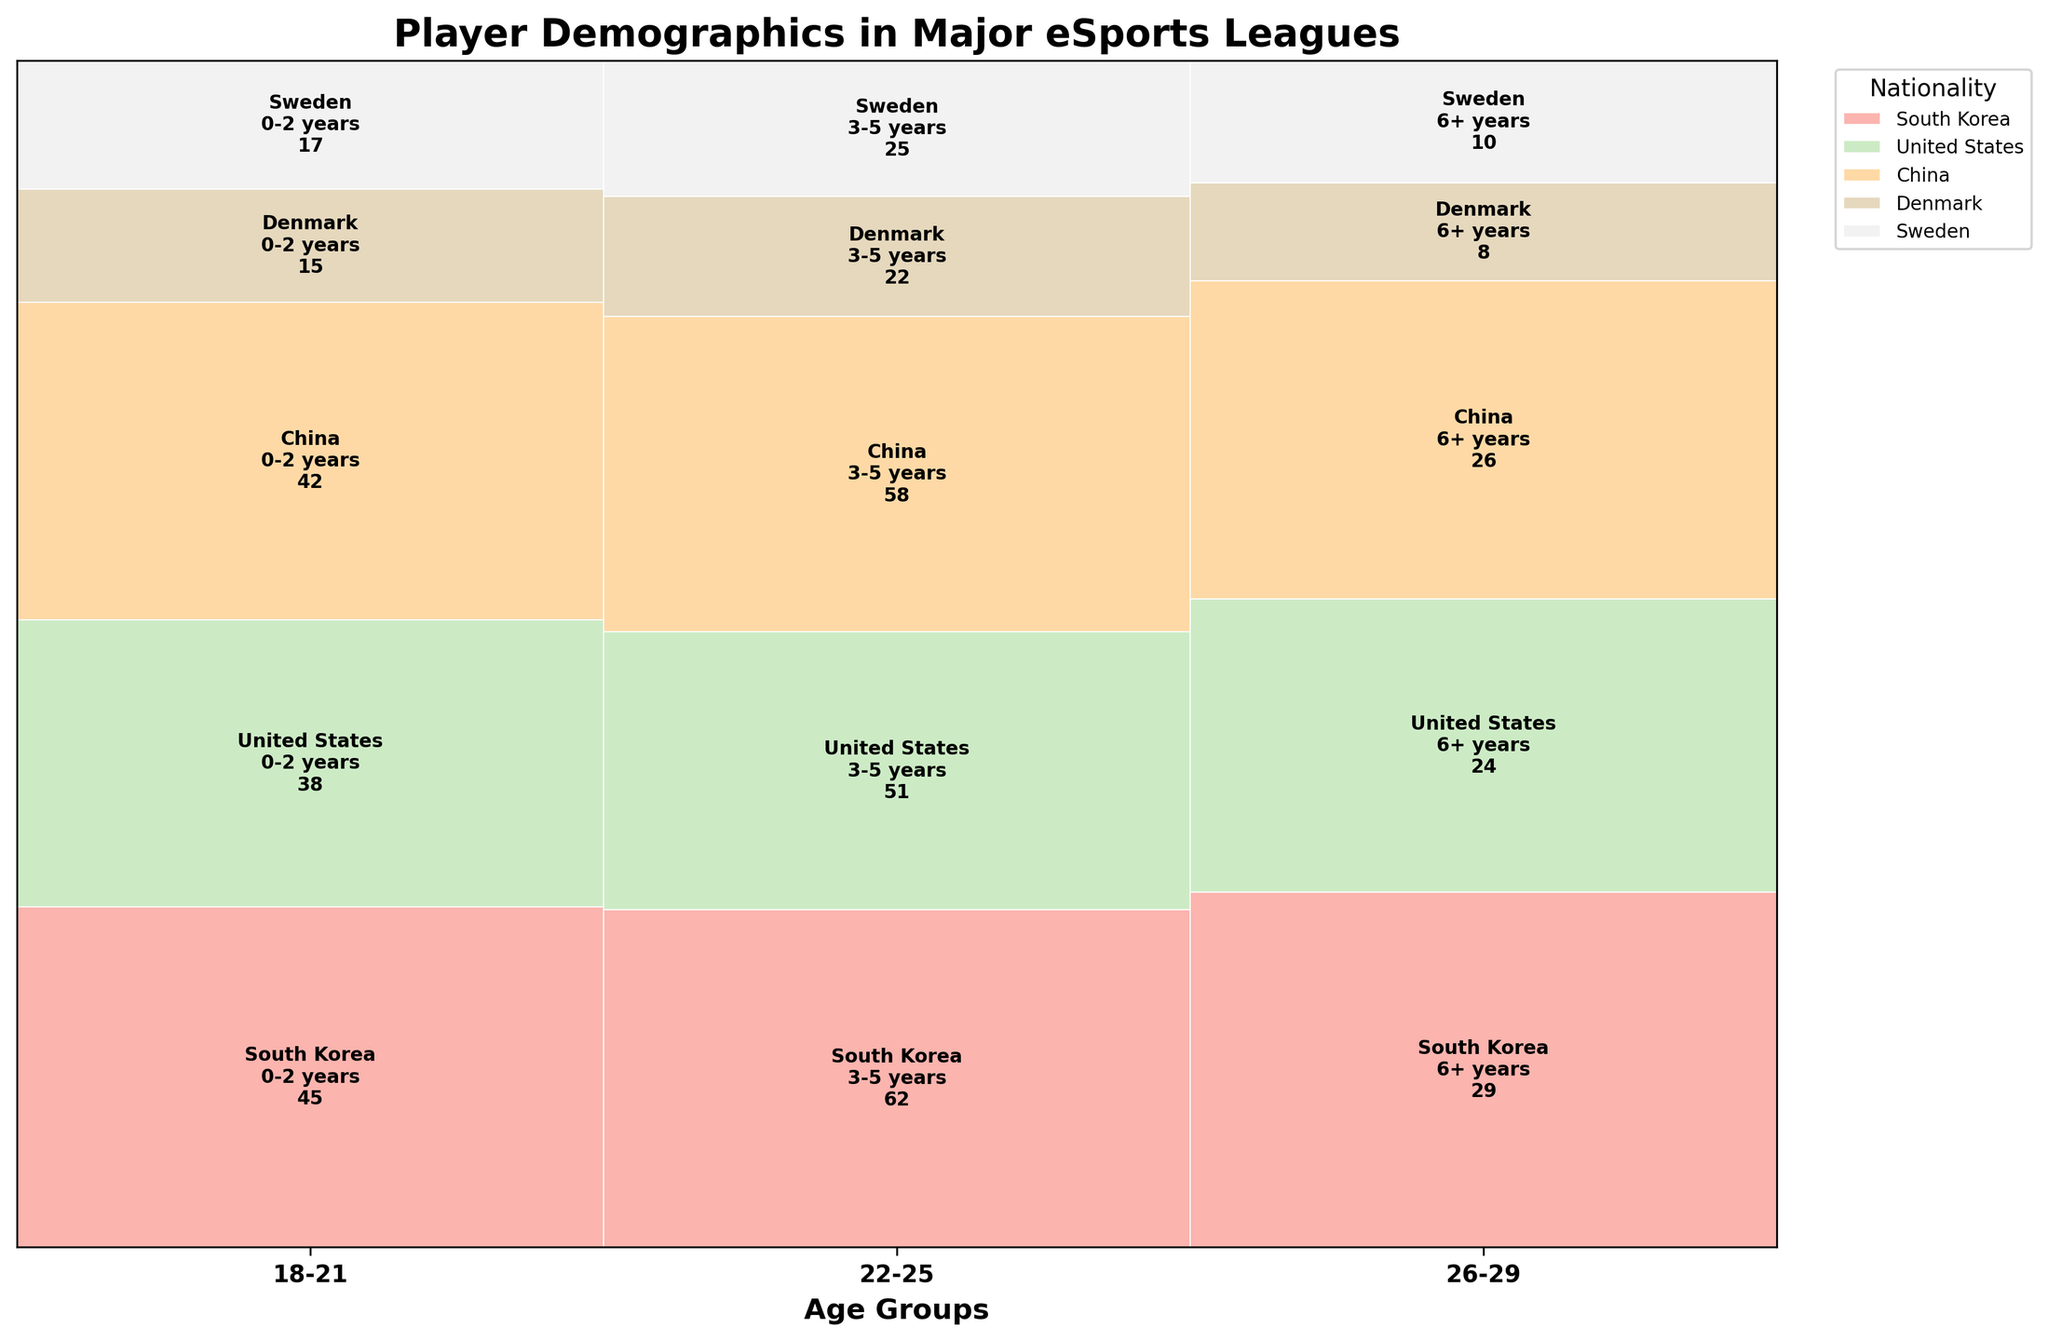What is the title of the plot? The title of the plot is displayed at the top of the figure in bold.
Answer: Player Demographics in Major eSports Leagues What colors are used to represent different nationalities? The colors for each nationality can be seen in the legend on the right side of the plot.
Answer: Pastel colors Which age group has the highest count for South Korean players with 3-5 years of professional experience? To find this, look at the segment for South Korean players within the 22-25 age group and compare it to other segments. The height of this segment will be taller than others within this demographic.
Answer: 22-25 How many players are there aged 26-29 with 6+ years of experience from the United States? Locate the 26-29 age group and find the segment corresponding to the United States with 6+ years of experience. The count should be indicated within the segment.
Answer: 24 Which nationality has the least number of players aged 18-21 with 0-2 years of experience? Determine this by comparing the segments corresponding to each nationality within the 18-21 age group and 0-2 years of experience. The smallest segment will indicate the least number of players.
Answer: Denmark Compare the total number of players aged 22-25 to those aged 26-29. Which group is larger? Sum the counts for all nationalities and professional experiences within the 22-25 and 26-29 age groups. Then compare these sums to see which is larger.
Answer: 22-25 Which nationality has the most diverse age groups represented? Look at the total number of segments for each nationality and count the unique age groups depicted in each. The nationality with three distinct age group segments is the most diverse.
Answer: Sweden What is the total count of Chinese players across all age groups and professional experience levels? Sum the counts of all segments that correspond to Chinese players across different age groups and professional experience levels.
Answer: 126 For South Korean players with 6+ years of experience, which age group do they mostly belong to? Look at the segments for South Korean players with 6+ years of experience in the 26-29 age group and compare their heights to other age groups within this experience category.
Answer: 26-29 Which group has more players: United States players aged 22-25 with 3-5 years of experience or Chinese players aged 18-21 with 0-2 years of experience? Compare the counts of United States players in the 22-25 age group with 3-5 years of experience to Chinese players in the 18-21 age group with 0-2 years of experience.
Answer: United States players aged 22-25 with 3-5 years 